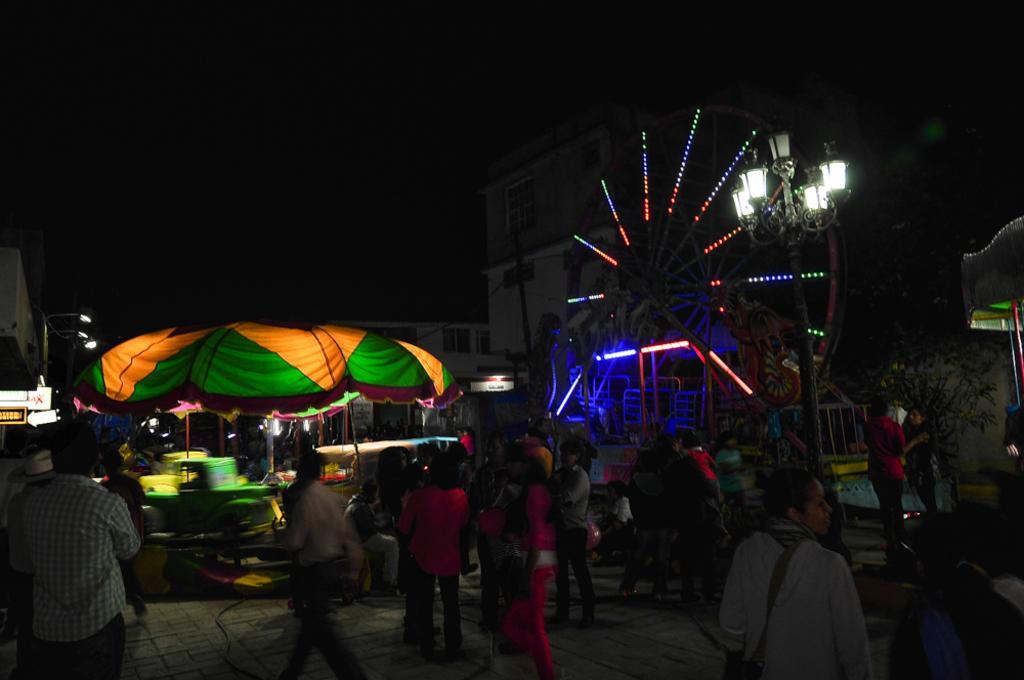Describe this image in one or two sentences. In this image we can see many persons on the ground. On the right side of the image we can see street pole, giant wheel, building. On the left side of the image we can see umbrella, persons, street lights and building. In the background there is a sky. 